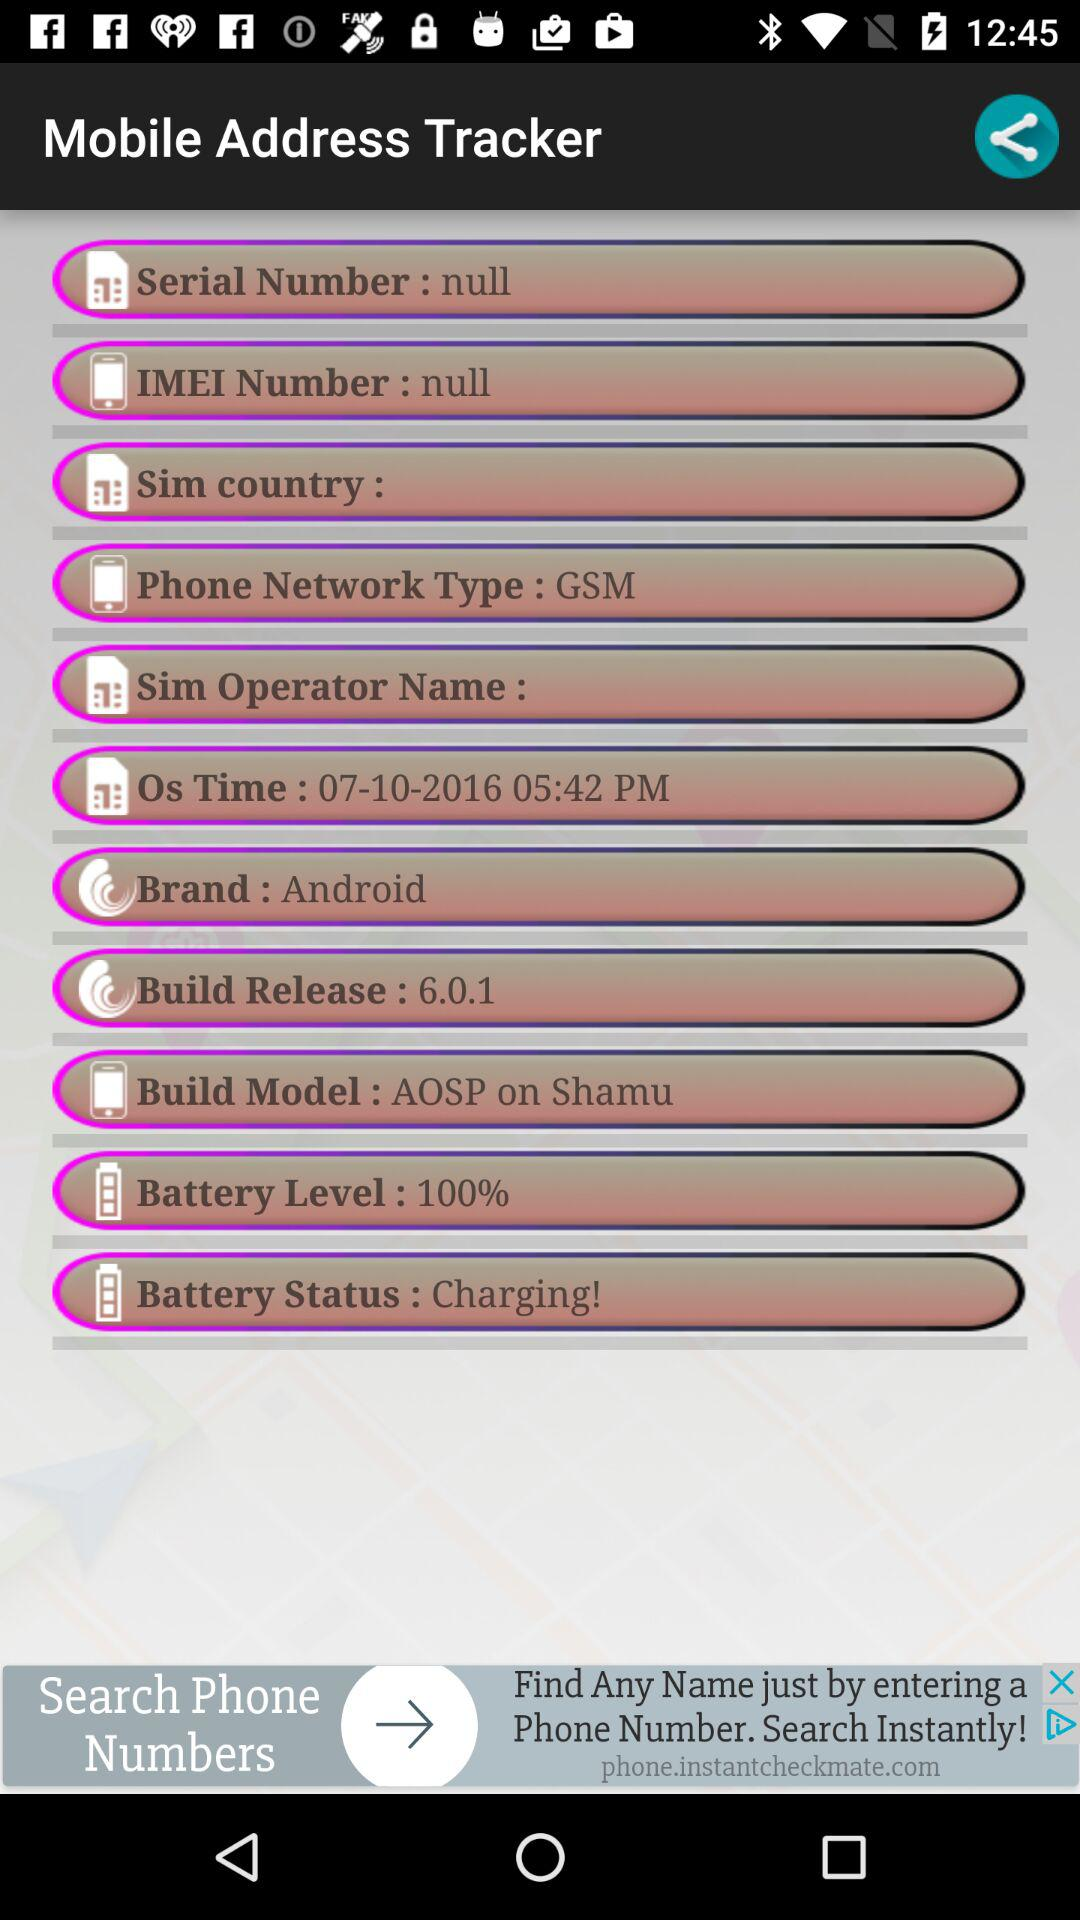What is the "Battery Level"? The "Battery Level" is 100%. 